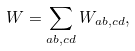Convert formula to latex. <formula><loc_0><loc_0><loc_500><loc_500>W = \sum _ { a b , c d } W _ { a b , c d } ,</formula> 